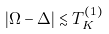Convert formula to latex. <formula><loc_0><loc_0><loc_500><loc_500>| \Omega - \Delta | \lesssim T _ { K } ^ { ( 1 ) }</formula> 